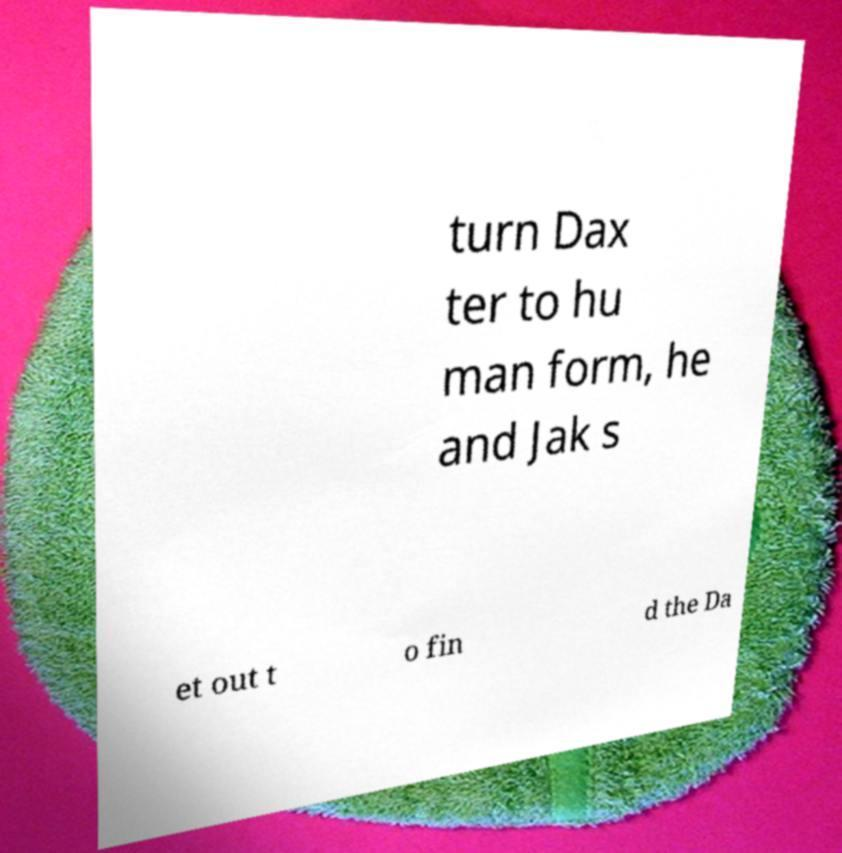Could you extract and type out the text from this image? turn Dax ter to hu man form, he and Jak s et out t o fin d the Da 